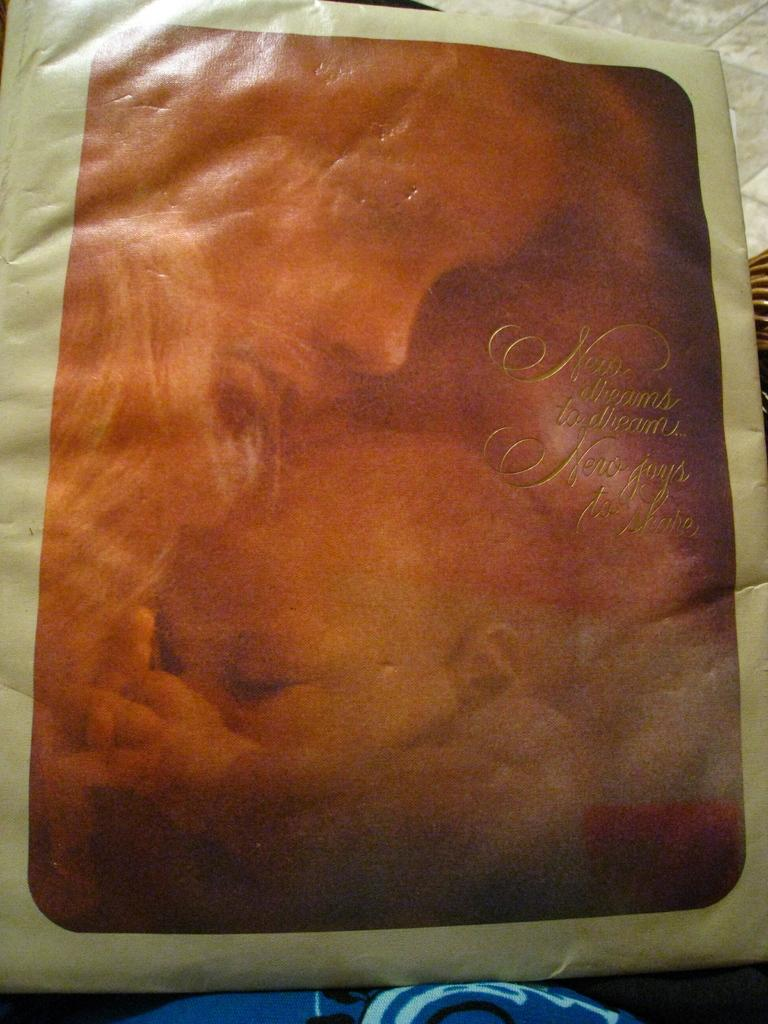What type of prints are visible in the image? There is a print of a person and a print of a baby in the image. What can be found on the cover of the prints? There are words on the cover of the print. What type of spark can be seen coming from the engine in the image? There is no engine or spark present in the image; it features prints of a person and a baby with words on the cover. 